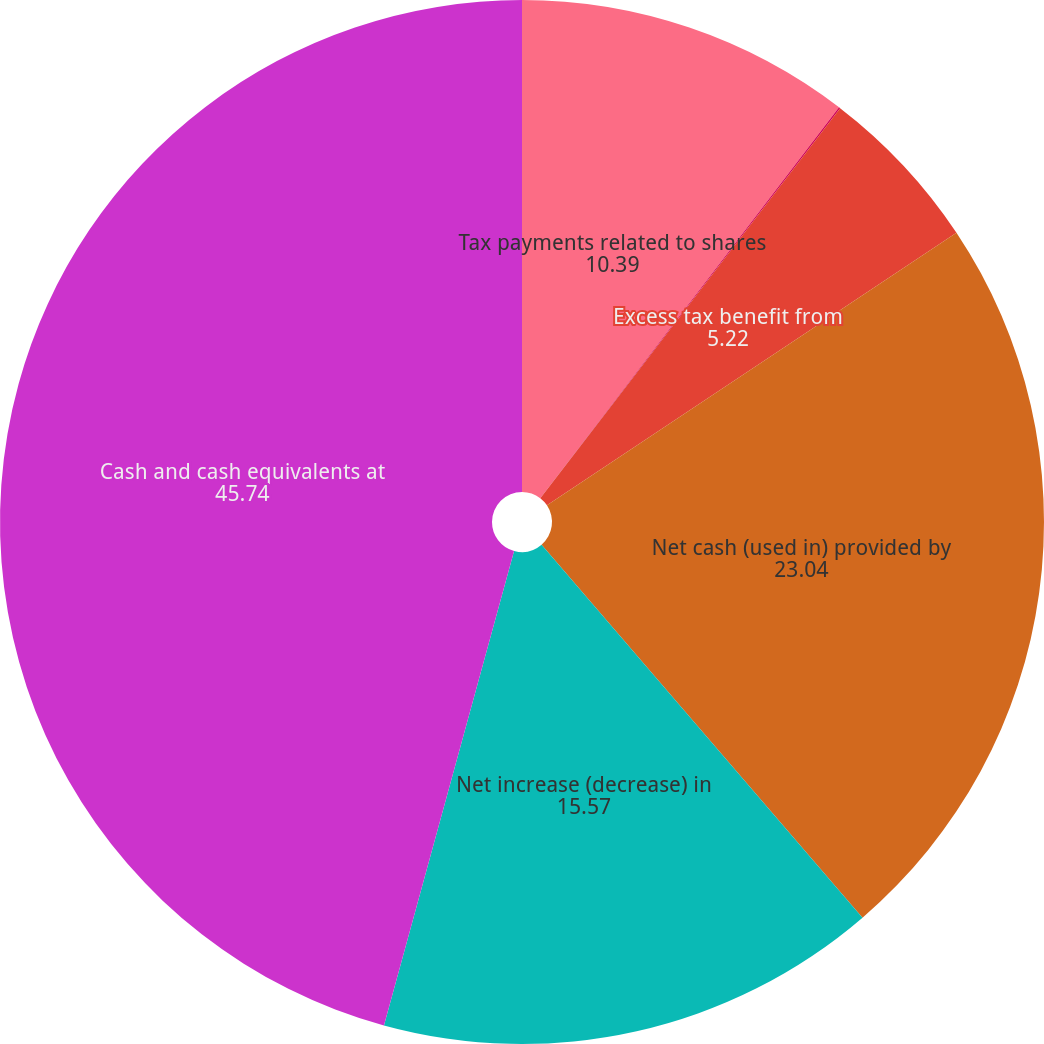<chart> <loc_0><loc_0><loc_500><loc_500><pie_chart><fcel>Tax payments related to shares<fcel>Capital lease payments<fcel>Excess tax benefit from<fcel>Net cash (used in) provided by<fcel>Net increase (decrease) in<fcel>Cash and cash equivalents at<nl><fcel>10.39%<fcel>0.04%<fcel>5.22%<fcel>23.04%<fcel>15.57%<fcel>45.74%<nl></chart> 